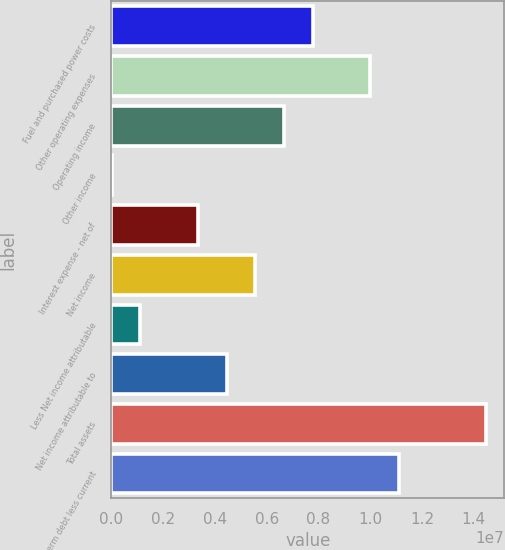Convert chart to OTSL. <chart><loc_0><loc_0><loc_500><loc_500><bar_chart><fcel>Fuel and purchased power costs<fcel>Other operating expenses<fcel>Operating income<fcel>Other income<fcel>Interest expense - net of<fcel>Net income<fcel>Less Net income attributable<fcel>Net income attributable to<fcel>Total assets<fcel>Long-term debt less current<nl><fcel>7.7873e+06<fcel>1.0012e+07<fcel>6.67495e+06<fcel>836<fcel>3.33789e+06<fcel>5.5626e+06<fcel>1.11319e+06<fcel>4.45025e+06<fcel>1.44614e+07<fcel>1.11244e+07<nl></chart> 